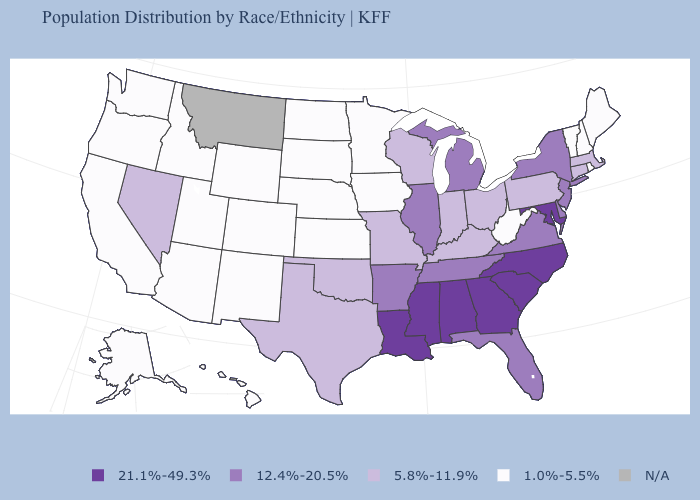What is the highest value in the USA?
Concise answer only. 21.1%-49.3%. Among the states that border Wisconsin , does Michigan have the highest value?
Answer briefly. Yes. Name the states that have a value in the range 1.0%-5.5%?
Quick response, please. Alaska, Arizona, California, Colorado, Hawaii, Idaho, Iowa, Kansas, Maine, Minnesota, Nebraska, New Hampshire, New Mexico, North Dakota, Oregon, Rhode Island, South Dakota, Utah, Vermont, Washington, West Virginia, Wyoming. Name the states that have a value in the range 5.8%-11.9%?
Write a very short answer. Connecticut, Indiana, Kentucky, Massachusetts, Missouri, Nevada, Ohio, Oklahoma, Pennsylvania, Texas, Wisconsin. Name the states that have a value in the range 12.4%-20.5%?
Be succinct. Arkansas, Delaware, Florida, Illinois, Michigan, New Jersey, New York, Tennessee, Virginia. How many symbols are there in the legend?
Answer briefly. 5. Name the states that have a value in the range N/A?
Be succinct. Montana. Which states have the highest value in the USA?
Keep it brief. Alabama, Georgia, Louisiana, Maryland, Mississippi, North Carolina, South Carolina. Which states have the lowest value in the USA?
Keep it brief. Alaska, Arizona, California, Colorado, Hawaii, Idaho, Iowa, Kansas, Maine, Minnesota, Nebraska, New Hampshire, New Mexico, North Dakota, Oregon, Rhode Island, South Dakota, Utah, Vermont, Washington, West Virginia, Wyoming. What is the value of South Carolina?
Short answer required. 21.1%-49.3%. Name the states that have a value in the range 1.0%-5.5%?
Short answer required. Alaska, Arizona, California, Colorado, Hawaii, Idaho, Iowa, Kansas, Maine, Minnesota, Nebraska, New Hampshire, New Mexico, North Dakota, Oregon, Rhode Island, South Dakota, Utah, Vermont, Washington, West Virginia, Wyoming. 